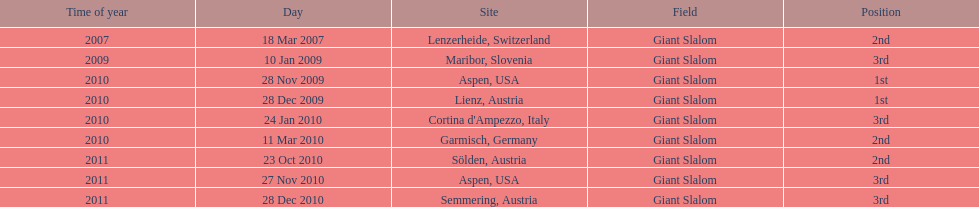The final race finishing place was not 1st but what other place? 3rd. 